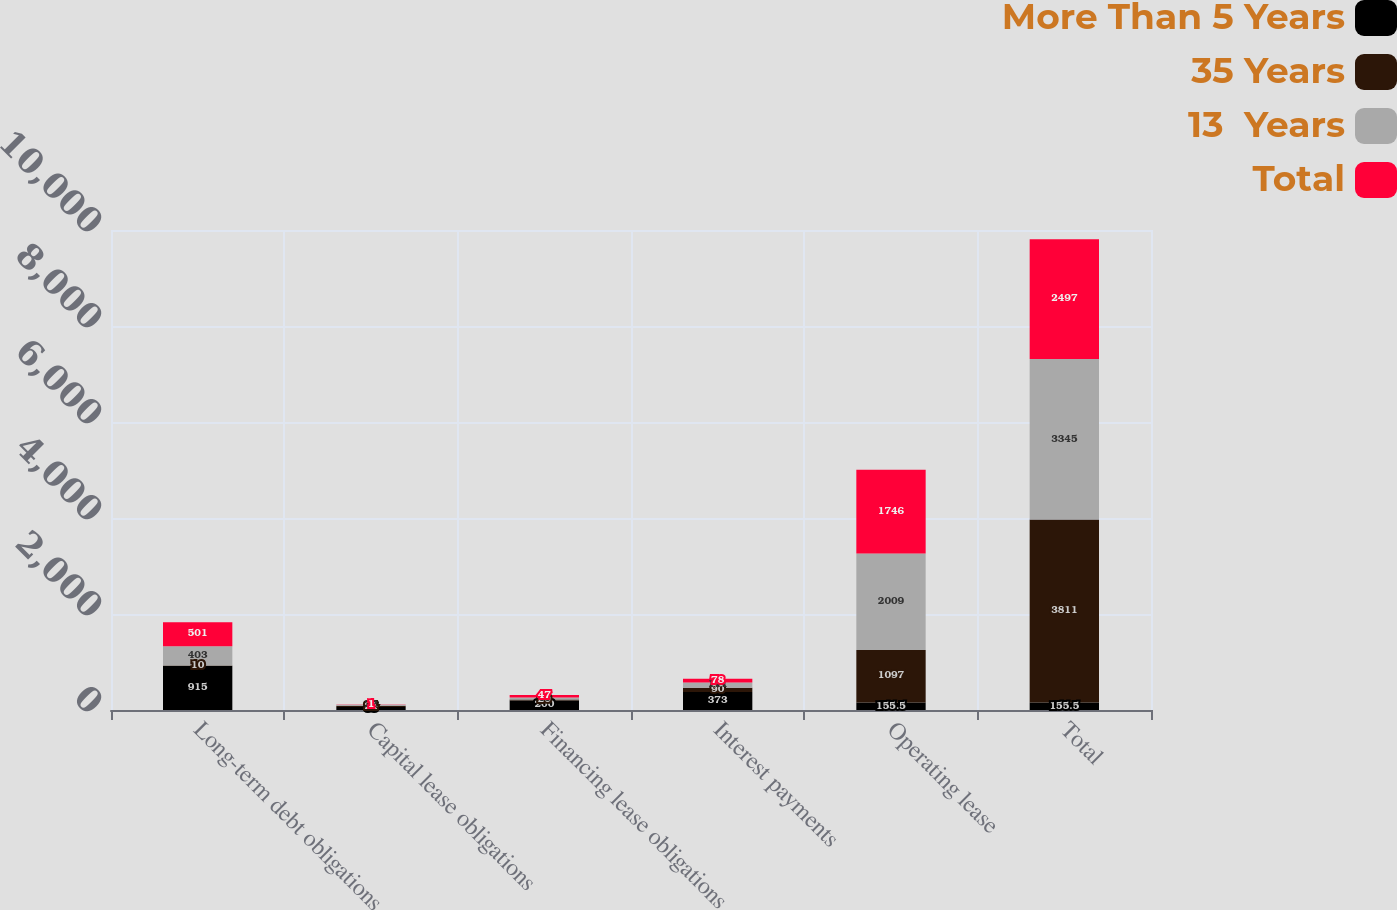<chart> <loc_0><loc_0><loc_500><loc_500><stacked_bar_chart><ecel><fcel>Long-term debt obligations<fcel>Capital lease obligations<fcel>Financing lease obligations<fcel>Interest payments<fcel>Operating lease<fcel>Total<nl><fcel>More Than 5 Years<fcel>915<fcel>65<fcel>200<fcel>373<fcel>155.5<fcel>155.5<nl><fcel>35 Years<fcel>10<fcel>24<fcel>20<fcel>90<fcel>1097<fcel>3811<nl><fcel>13  Years<fcel>403<fcel>22<fcel>43<fcel>111<fcel>2009<fcel>3345<nl><fcel>Total<fcel>501<fcel>1<fcel>47<fcel>78<fcel>1746<fcel>2497<nl></chart> 